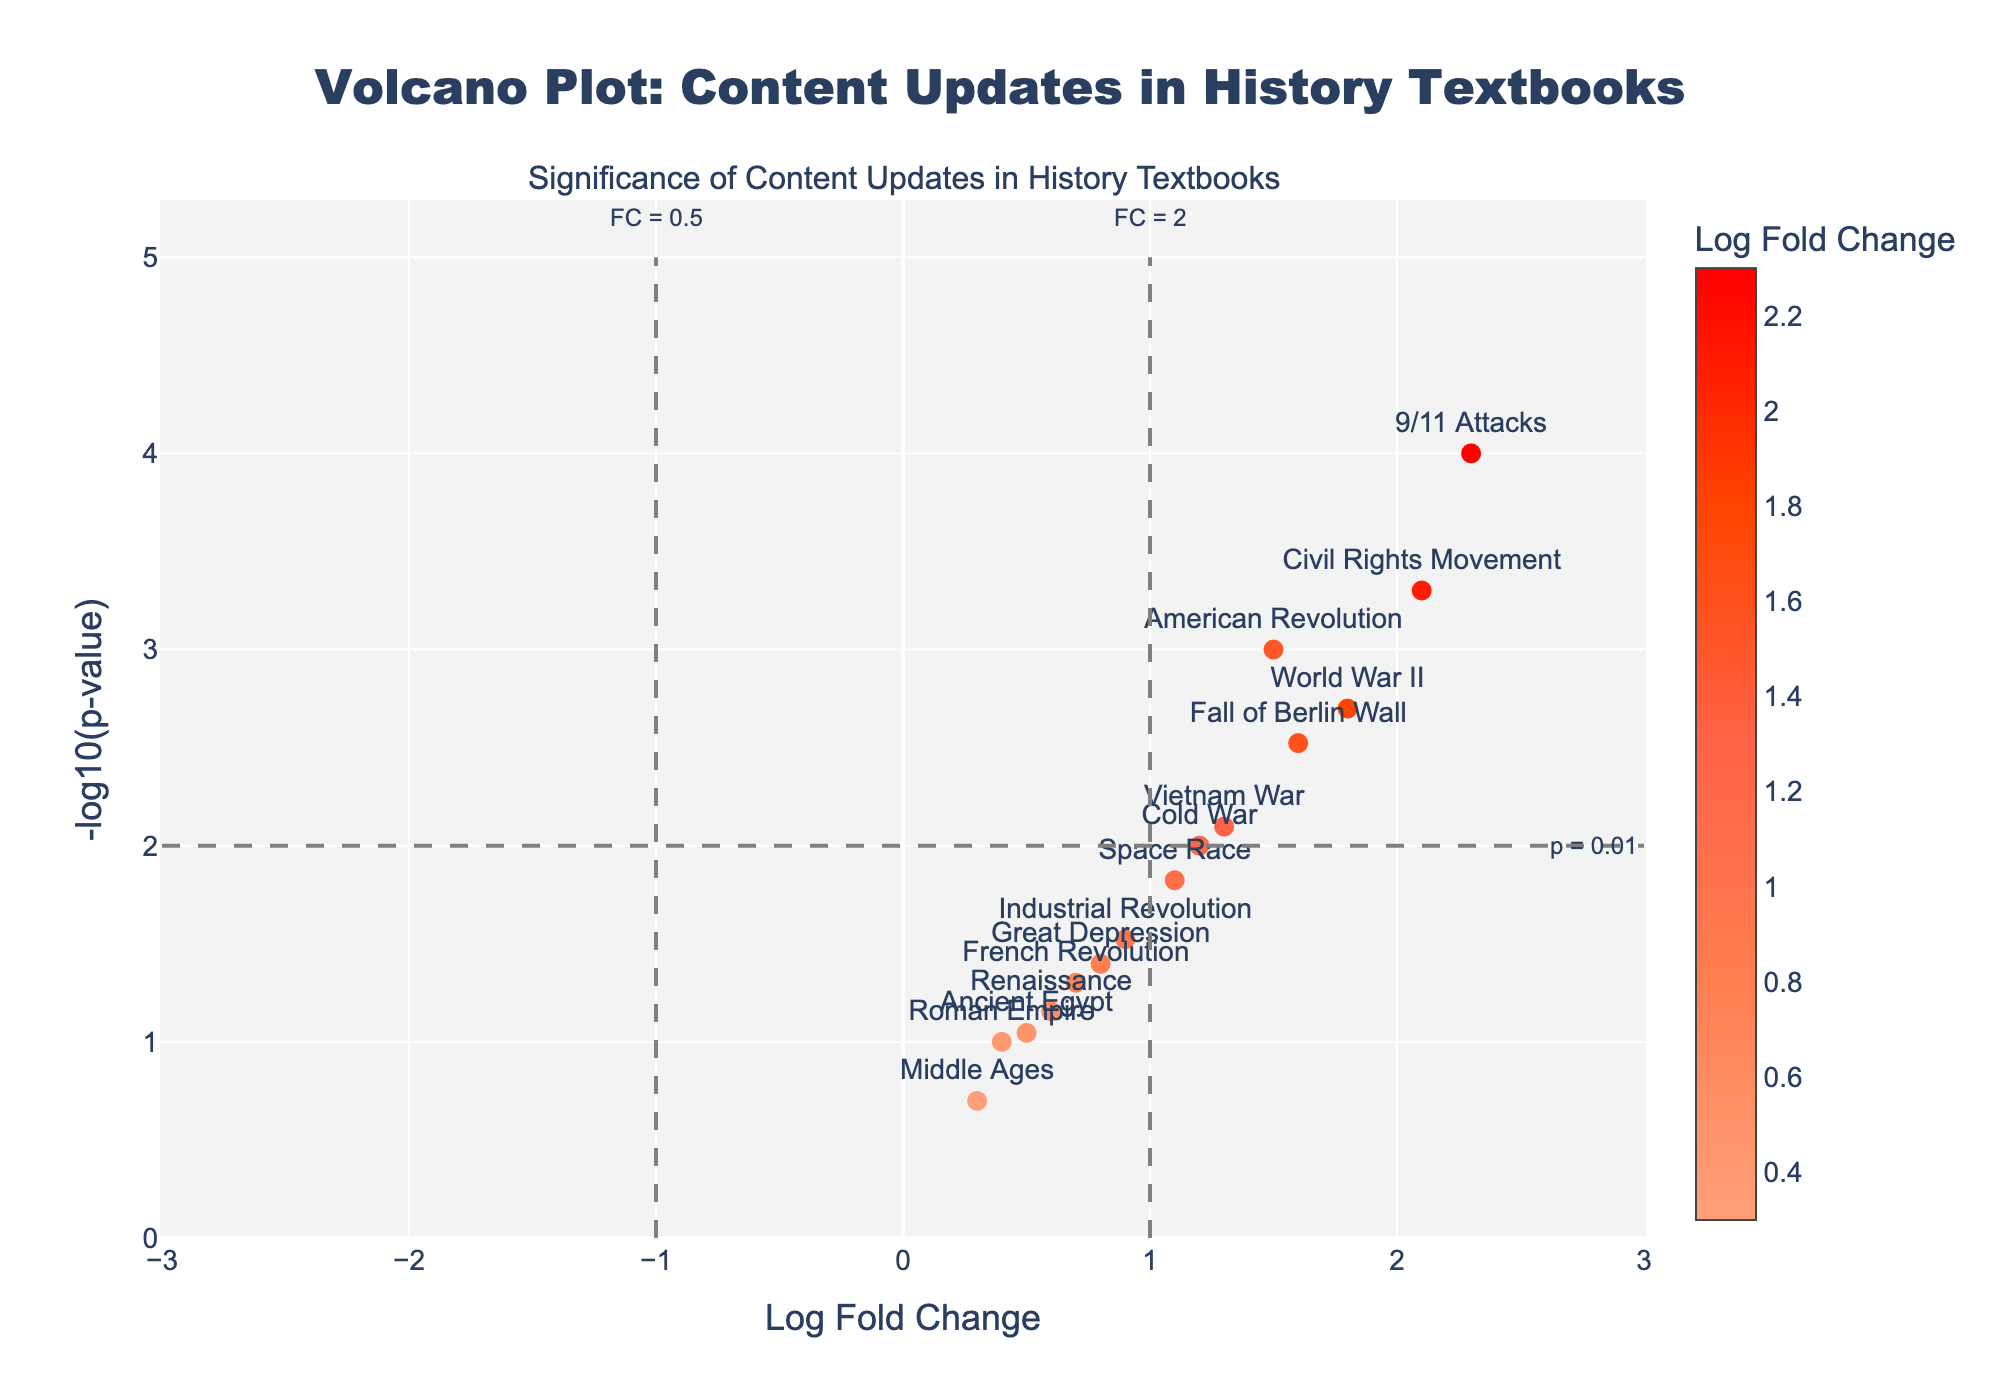How many content updates show a p-value less than 0.01? By looking at the y-axis scale (-log10(p-value)), content updates with p-values less than 0.01 will have values greater than 2. There are six points above this line including "American Revolution," "Civil Rights Movement," "World War II," "Fall of Berlin Wall," "9/11 Attacks," and "Vietnam War."
Answer: Six What is the content update with the highest log fold change? The x-axis shows the log fold change, with larger values to the right. The point farthest to the right is labeled "9/11 Attacks."
Answer: 9/11 Attacks Which content update has the lowest significance (highest p-value)? The point with the lowest -log10(p) value corresponds to the highest p-value. The point closest to the x-axis is labeled "Middle Ages."
Answer: Middle Ages What are the log fold change values for "American Revolution" and "French Revolution"? Look at the x-axis and locate the markers labeled "American Revolution" and "French Revolution." "American Revolution" is at 1.5 and "French Revolution" is at 0.7.
Answer: 1.5 and 0.7 Which content updates are considered significant with a p-value threshold of 0.05? Content updates with -log10(p) value greater than -log10(0.05) are significant. Since -log10(0.05) is around 1.3, updates "American Revolution," "Civil Rights Movement," "World War II," "Vietnam War," "Fall of Berlin Wall," "9/11 Attacks," and "Cold War" have values above this threshold.
Answer: American Revolution, Civil Rights Movement, World War II, Vietnam War, Fall of Berlin Wall, 9/11 Attacks, Cold War For the "Space Race," what is its log fold change and p-value? Locate the marker labeled "Space Race." The hover text indicates a log fold change of 1.1 and a p-value of 0.015.
Answer: 1.1 and 0.015 Which two content updates have the most similar log fold change values? Look for points that are horizontally closest to each other. "Cold War" at 1.2 and "Space Race" at 1.1 are the most similar in log fold change values.
Answer: Cold War and Space Race 